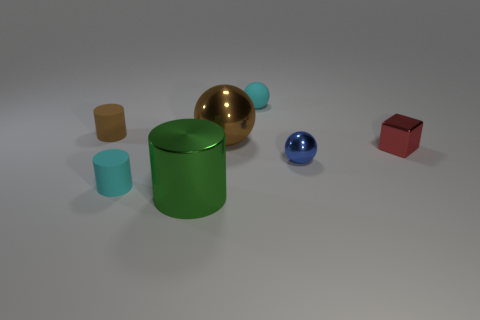How many tiny cyan spheres are made of the same material as the large cylinder?
Your answer should be very brief. 0. How many tiny spheres are right of the big green metallic cylinder that is to the left of the big brown ball?
Your response must be concise. 2. Is the color of the rubber thing in front of the blue sphere the same as the big shiny thing that is right of the green object?
Provide a succinct answer. No. The metal object that is behind the tiny blue shiny thing and on the left side of the cyan sphere has what shape?
Provide a succinct answer. Sphere. Is there a tiny cyan thing of the same shape as the red thing?
Keep it short and to the point. No. There is a blue object that is the same size as the brown matte object; what shape is it?
Your answer should be very brief. Sphere. What material is the red block?
Give a very brief answer. Metal. There is a brown metal sphere on the right side of the tiny cyan object in front of the small sphere that is to the left of the small blue thing; what is its size?
Offer a very short reply. Large. There is a small cylinder that is the same color as the large sphere; what is it made of?
Give a very brief answer. Rubber. How many rubber objects are either big brown balls or large cylinders?
Give a very brief answer. 0. 